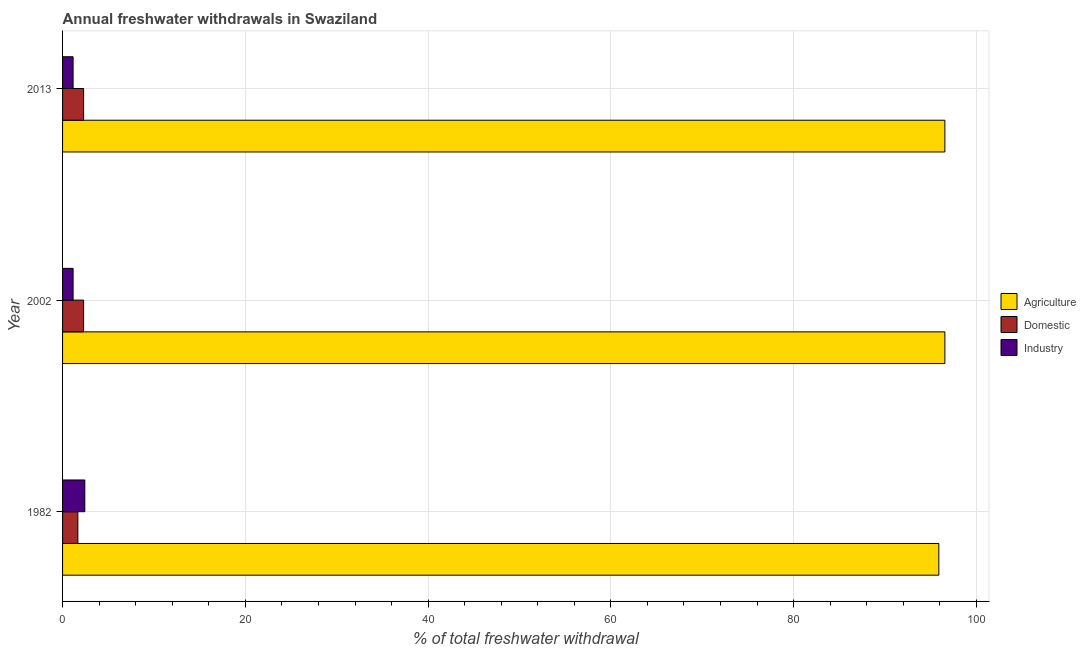Are the number of bars on each tick of the Y-axis equal?
Offer a very short reply. Yes. What is the label of the 1st group of bars from the top?
Offer a very short reply. 2013. In how many cases, is the number of bars for a given year not equal to the number of legend labels?
Offer a very short reply. 0. What is the percentage of freshwater withdrawal for industry in 1982?
Provide a succinct answer. 2.44. Across all years, what is the maximum percentage of freshwater withdrawal for domestic purposes?
Offer a very short reply. 2.3. Across all years, what is the minimum percentage of freshwater withdrawal for agriculture?
Provide a short and direct response. 95.89. What is the total percentage of freshwater withdrawal for domestic purposes in the graph?
Give a very brief answer. 6.28. What is the difference between the percentage of freshwater withdrawal for agriculture in 2002 and that in 2013?
Your response must be concise. 0. What is the difference between the percentage of freshwater withdrawal for agriculture in 1982 and the percentage of freshwater withdrawal for industry in 2013?
Ensure brevity in your answer.  94.74. What is the average percentage of freshwater withdrawal for domestic purposes per year?
Your answer should be compact. 2.09. In the year 2002, what is the difference between the percentage of freshwater withdrawal for domestic purposes and percentage of freshwater withdrawal for agriculture?
Ensure brevity in your answer.  -94.25. In how many years, is the percentage of freshwater withdrawal for industry greater than 84 %?
Offer a very short reply. 0. What is the ratio of the percentage of freshwater withdrawal for domestic purposes in 1982 to that in 2002?
Your response must be concise. 0.73. What is the difference between the highest and the lowest percentage of freshwater withdrawal for industry?
Provide a succinct answer. 1.28. Is the sum of the percentage of freshwater withdrawal for industry in 1982 and 2002 greater than the maximum percentage of freshwater withdrawal for agriculture across all years?
Your answer should be compact. No. What does the 3rd bar from the top in 2002 represents?
Give a very brief answer. Agriculture. What does the 2nd bar from the bottom in 1982 represents?
Your response must be concise. Domestic. Is it the case that in every year, the sum of the percentage of freshwater withdrawal for agriculture and percentage of freshwater withdrawal for domestic purposes is greater than the percentage of freshwater withdrawal for industry?
Your response must be concise. Yes. How many bars are there?
Ensure brevity in your answer.  9. Does the graph contain grids?
Give a very brief answer. Yes. Where does the legend appear in the graph?
Ensure brevity in your answer.  Center right. How many legend labels are there?
Your answer should be compact. 3. What is the title of the graph?
Offer a terse response. Annual freshwater withdrawals in Swaziland. Does "Central government" appear as one of the legend labels in the graph?
Provide a succinct answer. No. What is the label or title of the X-axis?
Your answer should be compact. % of total freshwater withdrawal. What is the % of total freshwater withdrawal of Agriculture in 1982?
Make the answer very short. 95.89. What is the % of total freshwater withdrawal in Domestic in 1982?
Keep it short and to the point. 1.67. What is the % of total freshwater withdrawal of Industry in 1982?
Provide a short and direct response. 2.44. What is the % of total freshwater withdrawal in Agriculture in 2002?
Your answer should be very brief. 96.55. What is the % of total freshwater withdrawal of Domestic in 2002?
Ensure brevity in your answer.  2.3. What is the % of total freshwater withdrawal in Industry in 2002?
Your answer should be compact. 1.15. What is the % of total freshwater withdrawal in Agriculture in 2013?
Make the answer very short. 96.55. What is the % of total freshwater withdrawal in Domestic in 2013?
Your answer should be compact. 2.3. What is the % of total freshwater withdrawal in Industry in 2013?
Offer a very short reply. 1.15. Across all years, what is the maximum % of total freshwater withdrawal in Agriculture?
Provide a short and direct response. 96.55. Across all years, what is the maximum % of total freshwater withdrawal in Domestic?
Your response must be concise. 2.3. Across all years, what is the maximum % of total freshwater withdrawal of Industry?
Your answer should be very brief. 2.44. Across all years, what is the minimum % of total freshwater withdrawal in Agriculture?
Your answer should be very brief. 95.89. Across all years, what is the minimum % of total freshwater withdrawal in Domestic?
Keep it short and to the point. 1.67. Across all years, what is the minimum % of total freshwater withdrawal in Industry?
Offer a terse response. 1.15. What is the total % of total freshwater withdrawal of Agriculture in the graph?
Make the answer very short. 288.99. What is the total % of total freshwater withdrawal in Domestic in the graph?
Provide a succinct answer. 6.28. What is the total % of total freshwater withdrawal of Industry in the graph?
Offer a terse response. 4.74. What is the difference between the % of total freshwater withdrawal in Agriculture in 1982 and that in 2002?
Give a very brief answer. -0.66. What is the difference between the % of total freshwater withdrawal in Domestic in 1982 and that in 2002?
Offer a terse response. -0.63. What is the difference between the % of total freshwater withdrawal of Industry in 1982 and that in 2002?
Keep it short and to the point. 1.28. What is the difference between the % of total freshwater withdrawal in Agriculture in 1982 and that in 2013?
Keep it short and to the point. -0.66. What is the difference between the % of total freshwater withdrawal of Domestic in 1982 and that in 2013?
Give a very brief answer. -0.63. What is the difference between the % of total freshwater withdrawal in Industry in 1982 and that in 2013?
Keep it short and to the point. 1.28. What is the difference between the % of total freshwater withdrawal of Agriculture in 1982 and the % of total freshwater withdrawal of Domestic in 2002?
Ensure brevity in your answer.  93.59. What is the difference between the % of total freshwater withdrawal of Agriculture in 1982 and the % of total freshwater withdrawal of Industry in 2002?
Your response must be concise. 94.74. What is the difference between the % of total freshwater withdrawal of Domestic in 1982 and the % of total freshwater withdrawal of Industry in 2002?
Keep it short and to the point. 0.52. What is the difference between the % of total freshwater withdrawal in Agriculture in 1982 and the % of total freshwater withdrawal in Domestic in 2013?
Provide a short and direct response. 93.59. What is the difference between the % of total freshwater withdrawal in Agriculture in 1982 and the % of total freshwater withdrawal in Industry in 2013?
Your answer should be compact. 94.74. What is the difference between the % of total freshwater withdrawal of Domestic in 1982 and the % of total freshwater withdrawal of Industry in 2013?
Make the answer very short. 0.52. What is the difference between the % of total freshwater withdrawal in Agriculture in 2002 and the % of total freshwater withdrawal in Domestic in 2013?
Make the answer very short. 94.25. What is the difference between the % of total freshwater withdrawal in Agriculture in 2002 and the % of total freshwater withdrawal in Industry in 2013?
Keep it short and to the point. 95.4. What is the difference between the % of total freshwater withdrawal in Domestic in 2002 and the % of total freshwater withdrawal in Industry in 2013?
Make the answer very short. 1.15. What is the average % of total freshwater withdrawal of Agriculture per year?
Your answer should be very brief. 96.33. What is the average % of total freshwater withdrawal of Domestic per year?
Provide a succinct answer. 2.09. What is the average % of total freshwater withdrawal in Industry per year?
Provide a short and direct response. 1.58. In the year 1982, what is the difference between the % of total freshwater withdrawal in Agriculture and % of total freshwater withdrawal in Domestic?
Offer a very short reply. 94.22. In the year 1982, what is the difference between the % of total freshwater withdrawal of Agriculture and % of total freshwater withdrawal of Industry?
Offer a very short reply. 93.45. In the year 1982, what is the difference between the % of total freshwater withdrawal in Domestic and % of total freshwater withdrawal in Industry?
Provide a short and direct response. -0.76. In the year 2002, what is the difference between the % of total freshwater withdrawal in Agriculture and % of total freshwater withdrawal in Domestic?
Provide a short and direct response. 94.25. In the year 2002, what is the difference between the % of total freshwater withdrawal of Agriculture and % of total freshwater withdrawal of Industry?
Offer a terse response. 95.4. In the year 2002, what is the difference between the % of total freshwater withdrawal in Domestic and % of total freshwater withdrawal in Industry?
Make the answer very short. 1.15. In the year 2013, what is the difference between the % of total freshwater withdrawal in Agriculture and % of total freshwater withdrawal in Domestic?
Provide a short and direct response. 94.25. In the year 2013, what is the difference between the % of total freshwater withdrawal in Agriculture and % of total freshwater withdrawal in Industry?
Provide a succinct answer. 95.4. In the year 2013, what is the difference between the % of total freshwater withdrawal in Domestic and % of total freshwater withdrawal in Industry?
Offer a terse response. 1.15. What is the ratio of the % of total freshwater withdrawal in Domestic in 1982 to that in 2002?
Give a very brief answer. 0.73. What is the ratio of the % of total freshwater withdrawal of Industry in 1982 to that in 2002?
Keep it short and to the point. 2.11. What is the ratio of the % of total freshwater withdrawal of Domestic in 1982 to that in 2013?
Ensure brevity in your answer.  0.73. What is the ratio of the % of total freshwater withdrawal in Industry in 1982 to that in 2013?
Keep it short and to the point. 2.11. What is the ratio of the % of total freshwater withdrawal of Domestic in 2002 to that in 2013?
Ensure brevity in your answer.  1. What is the ratio of the % of total freshwater withdrawal of Industry in 2002 to that in 2013?
Your answer should be compact. 1. What is the difference between the highest and the second highest % of total freshwater withdrawal in Industry?
Provide a succinct answer. 1.28. What is the difference between the highest and the lowest % of total freshwater withdrawal of Agriculture?
Ensure brevity in your answer.  0.66. What is the difference between the highest and the lowest % of total freshwater withdrawal of Domestic?
Ensure brevity in your answer.  0.63. What is the difference between the highest and the lowest % of total freshwater withdrawal in Industry?
Make the answer very short. 1.28. 